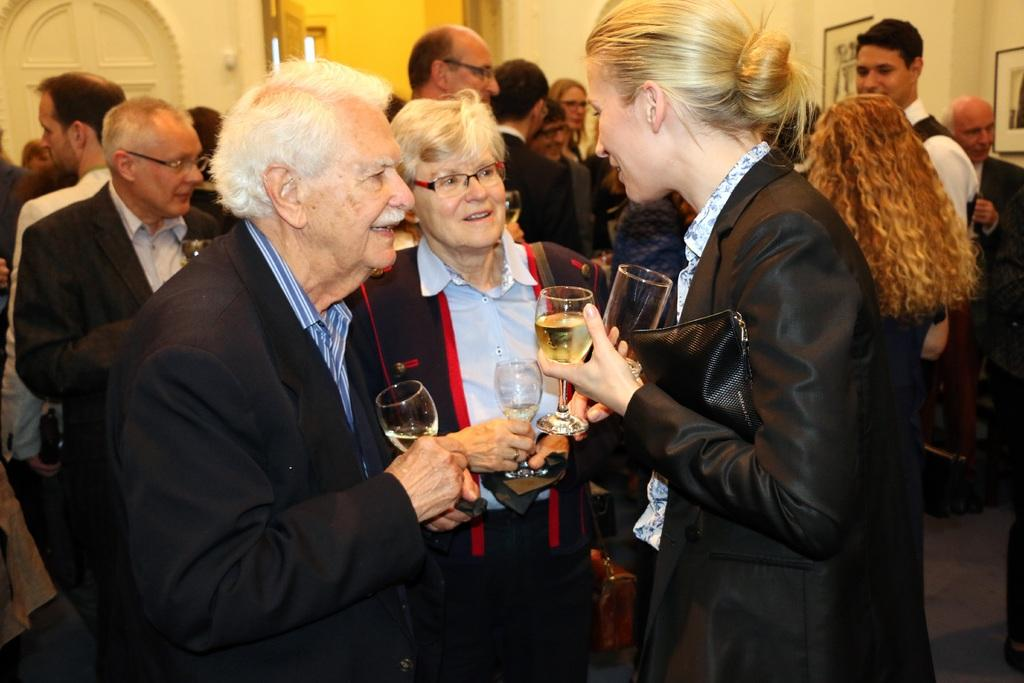What are the people in the image wearing? The persons in the image are wearing clothes. What are some of the people holding in their hands? Some persons are holding glasses in their hands. Where are the photo frames located in the image? The photo frames are in the top right of the image. What type of honey can be seen dripping from the photo frames in the image? There is no honey present in the image; it only features persons wearing clothes, holding glasses, and photo frames. 